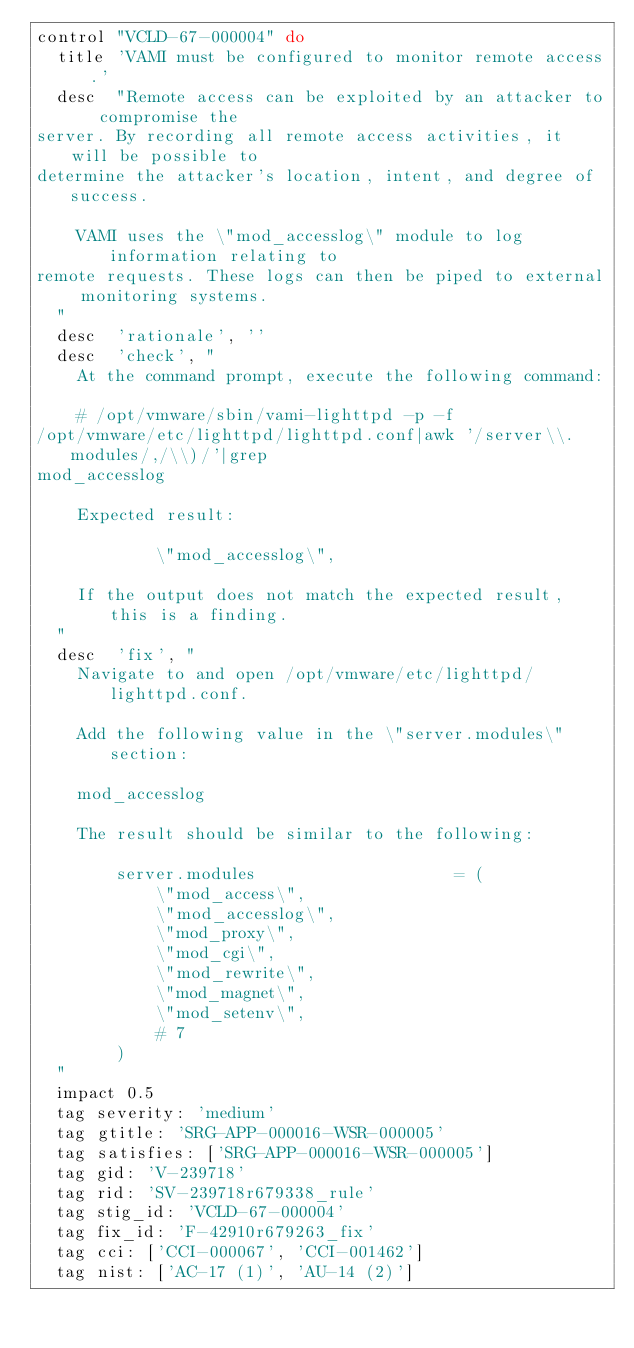Convert code to text. <code><loc_0><loc_0><loc_500><loc_500><_Ruby_>control "VCLD-67-000004" do
  title 'VAMI must be configured to monitor remote access.'
  desc  "Remote access can be exploited by an attacker to compromise the
server. By recording all remote access activities, it will be possible to
determine the attacker's location, intent, and degree of success.

    VAMI uses the \"mod_accesslog\" module to log information relating to
remote requests. These logs can then be piped to external monitoring systems.
  "
  desc  'rationale', ''
  desc  'check', "
    At the command prompt, execute the following command:

    # /opt/vmware/sbin/vami-lighttpd -p -f
/opt/vmware/etc/lighttpd/lighttpd.conf|awk '/server\\.modules/,/\\)/'|grep
mod_accesslog

    Expected result:

            \"mod_accesslog\",

    If the output does not match the expected result, this is a finding.
  "
  desc  'fix', "
    Navigate to and open /opt/vmware/etc/lighttpd/lighttpd.conf.

    Add the following value in the \"server.modules\" section:

    mod_accesslog

    The result should be similar to the following:

        server.modules                    = (
            \"mod_access\",
            \"mod_accesslog\",
            \"mod_proxy\",
            \"mod_cgi\",
            \"mod_rewrite\",
            \"mod_magnet\",
            \"mod_setenv\",
            # 7
        )
  "
  impact 0.5
  tag severity: 'medium'
  tag gtitle: 'SRG-APP-000016-WSR-000005'
  tag satisfies: ['SRG-APP-000016-WSR-000005']
  tag gid: 'V-239718'
  tag rid: 'SV-239718r679338_rule'
  tag stig_id: 'VCLD-67-000004'
  tag fix_id: 'F-42910r679263_fix'
  tag cci: ['CCI-000067', 'CCI-001462']
  tag nist: ['AC-17 (1)', 'AU-14 (2)']
</code> 